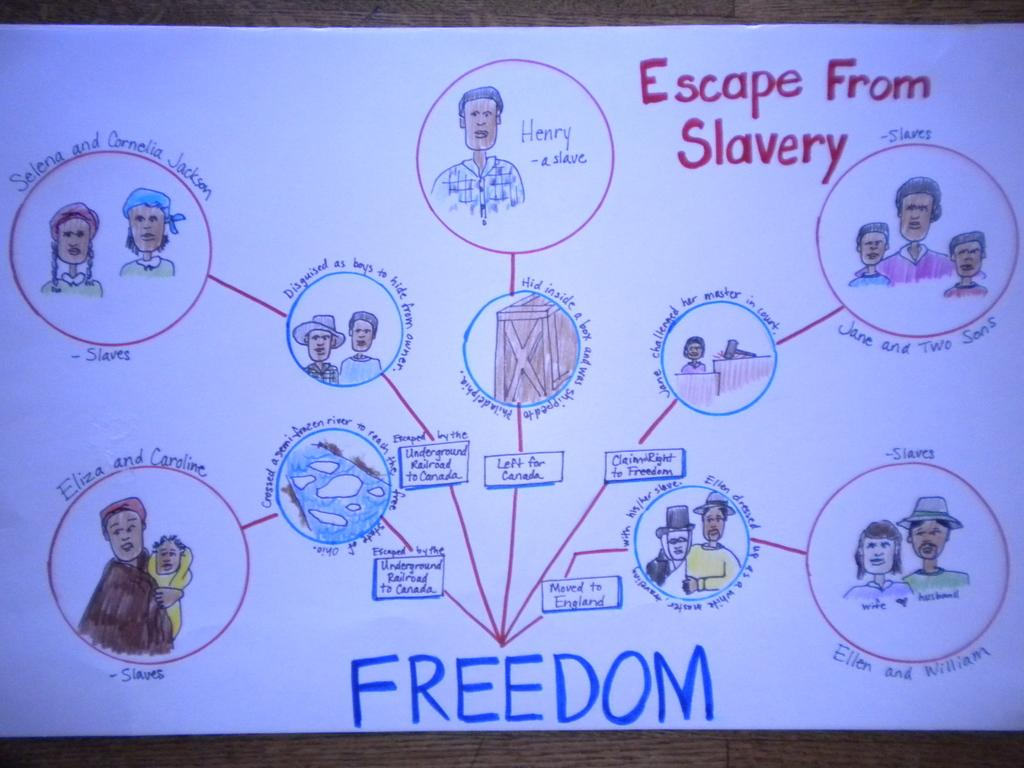What is the main subject of the image? The main subject of the image is a chart. What can be found on the chart? The chart contains sketches of persons and text. What type of territory is depicted in the image? There is no territory depicted in the image; it features a chart with sketches of persons and text. What emotion is being expressed by the persons in the image? The image does not depict emotions or expressions; it only shows sketches of persons and text on a chart. 